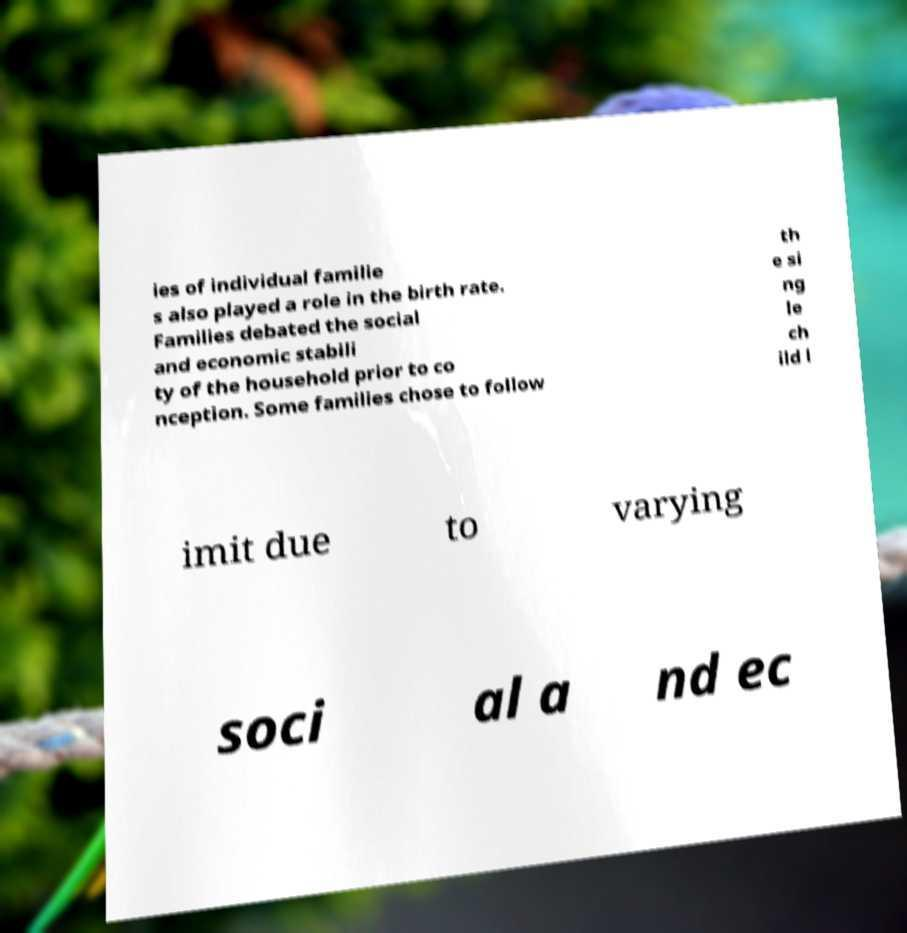Could you extract and type out the text from this image? ies of individual familie s also played a role in the birth rate. Families debated the social and economic stabili ty of the household prior to co nception. Some families chose to follow th e si ng le ch ild l imit due to varying soci al a nd ec 